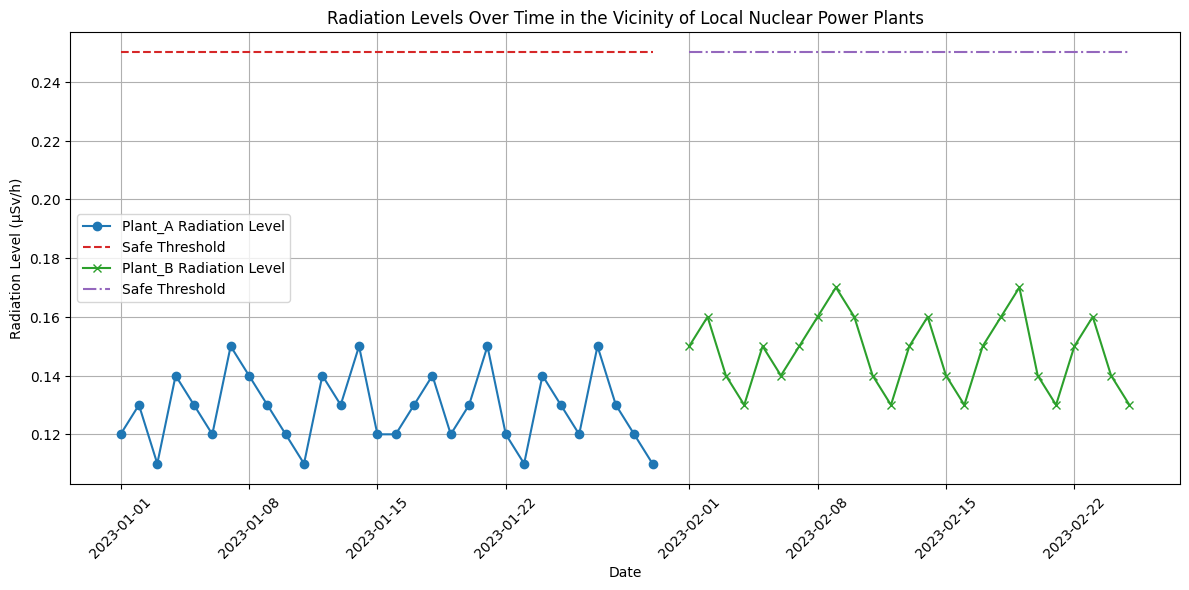What is the highest measured radiation level at Plant A? To find this, look at the points plotted for Plant A over the entire period and identify the highest value. The maximum point is 0.15 µSv/h on multiple dates.
Answer: 0.15 µSv/h Which plant has the higher average radiation level? First, calculate the average for Plant A and Plant B separately. For Plant A, add all radiation levels and divide by the number of measurements: (0.12+0.13+...0.12)/30 ≈ 0.13. For Plant B, do similarly: (0.15+0.16+...0.13)/25 ≈ 0.15. Compare the two averages to determine that Plant B has a higher average radiation level.
Answer: Plant B On which days did Plant B’s radiation levels exceed the safe threshold? To answer this, look for points where the radiation levels of Plant B (green line) are above the safe threshold (purple dashed line). These dates are February 9 and February 19.
Answer: February 9, February 19 Is there any day when the radiation level at Plant A was equal to the safe threshold? Check the points for Plant A and see if any of them align exactly with the safe threshold line for Plant A (red dashed line) which is constant at 0.25 µSv/h. No such intersection exists in the plot.
Answer: No How does the trend of radiation levels compare between Plant A and Plant B over time? Observe the pattern of both plants’ radiation levels. Plant A has a relatively stable or slightly fluctuating trend below 0.15 µSv/h, whereas Plant B's radiation levels have minor fluctuations and are generally steady, maintaining values around 0.15-0.17 µSv/h and slightly increasing but never reaching the safe threshold for most days. Summarize these observations.
Answer: Plant A is more stable; Plant B has minor fluctuations What is the difference between the highest and lowest radiation levels at Plant B? Identify the highest and lowest points on Plant B's plot. The highest is 0.17 µSv/h, and the lowest is 0.13 µSv/h. Subtract the lowest from the highest: 0.17 - 0.13 = 0.04 µSv/h.
Answer: 0.04 µSv/h Are there any days when radiation levels at both plants were equal? Cross-check dates for both Plant A and Plant B where their respective radiation levels are plotted. There are no dates where the radiation levels of both plants align exactly.
Answer: No Was there a consistent pattern of radiation levels exceeding the safe threshold at any plant? Examine the overall trends and any instances where radiation levels surpass the safe threshold for both plants throughout the plot's duration. Only isolated instances for Plant B on February 9 and 19 are exceeding the threshold, but no consistent pattern is observed.
Answer: No consistent pattern How many days did Plant A’s radiation levels fall below 0.12 µSv/h? Check all points plotted for Plant A and count the number of instances below 0.12 µSv/h. The dates are January 3, January 11, January 23, and January 30, making it 4 days in total.
Answer: 4 days 